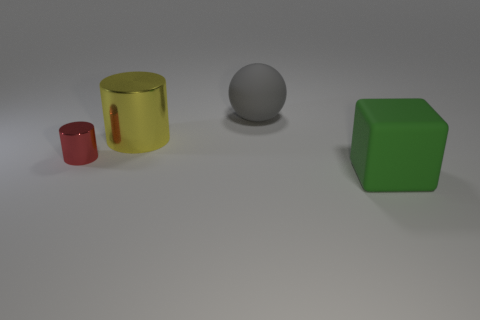There is another thing that is the same shape as the small metal thing; what is it made of?
Your answer should be very brief. Metal. How many big cubes are there?
Your response must be concise. 1. There is a matte thing that is on the right side of the rubber thing on the left side of the big matte thing right of the big gray rubber object; what is its color?
Ensure brevity in your answer.  Green. Is the number of green spheres less than the number of cubes?
Make the answer very short. Yes. There is a large thing that is the same shape as the tiny thing; what color is it?
Keep it short and to the point. Yellow. What color is the cube that is made of the same material as the large gray ball?
Ensure brevity in your answer.  Green. How many yellow cylinders have the same size as the matte block?
Provide a short and direct response. 1. What is the material of the small red thing?
Give a very brief answer. Metal. Are there more big green rubber objects than small blue metallic spheres?
Provide a succinct answer. Yes. Does the large yellow metallic object have the same shape as the red object?
Offer a terse response. Yes. 